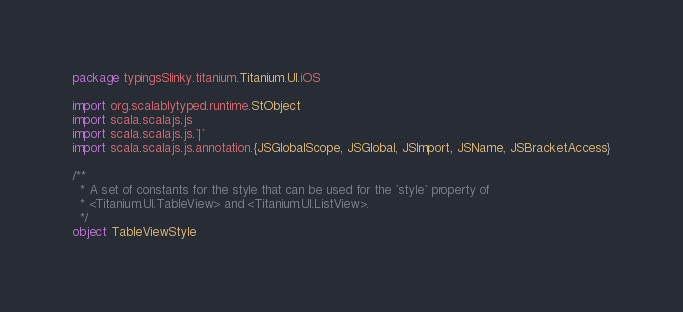<code> <loc_0><loc_0><loc_500><loc_500><_Scala_>package typingsSlinky.titanium.Titanium.UI.iOS

import org.scalablytyped.runtime.StObject
import scala.scalajs.js
import scala.scalajs.js.`|`
import scala.scalajs.js.annotation.{JSGlobalScope, JSGlobal, JSImport, JSName, JSBracketAccess}

/**
  * A set of constants for the style that can be used for the `style` property of
  * <Titanium.UI.TableView> and <Titanium.UI.ListView>.
  */
object TableViewStyle
</code> 